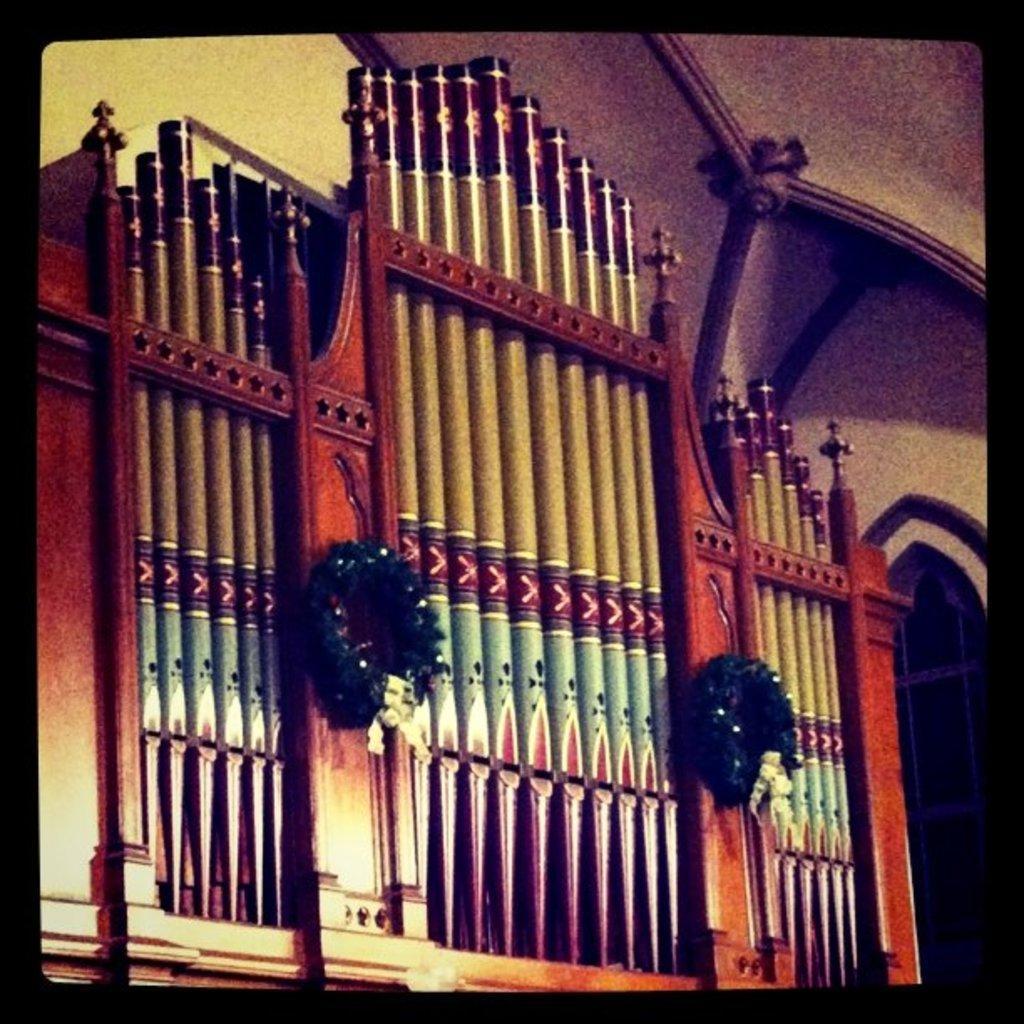In one or two sentences, can you explain what this image depicts? In this image we can see a wooden frame with two garlands on it, we can also see walls, around the image we can see the black color border. 